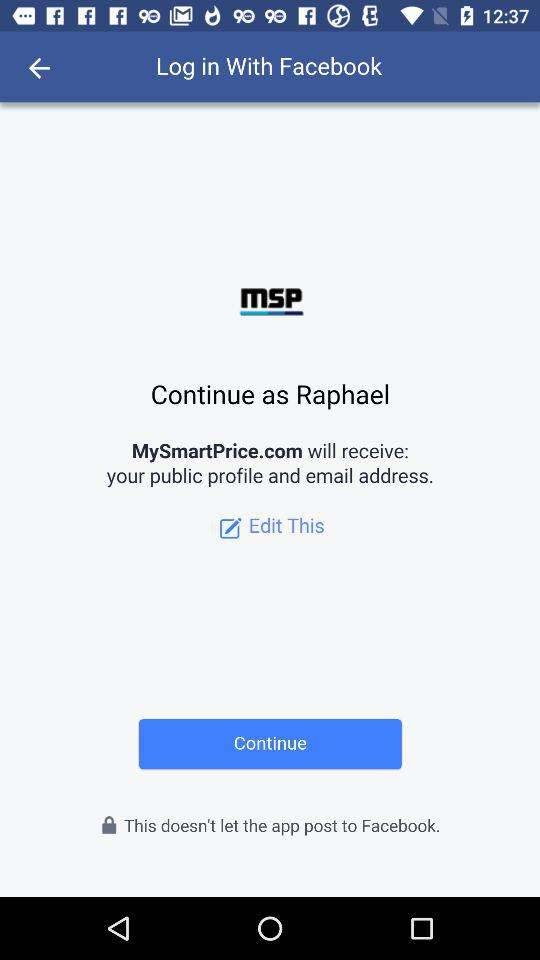What's the user name? The user name is Raphael. 